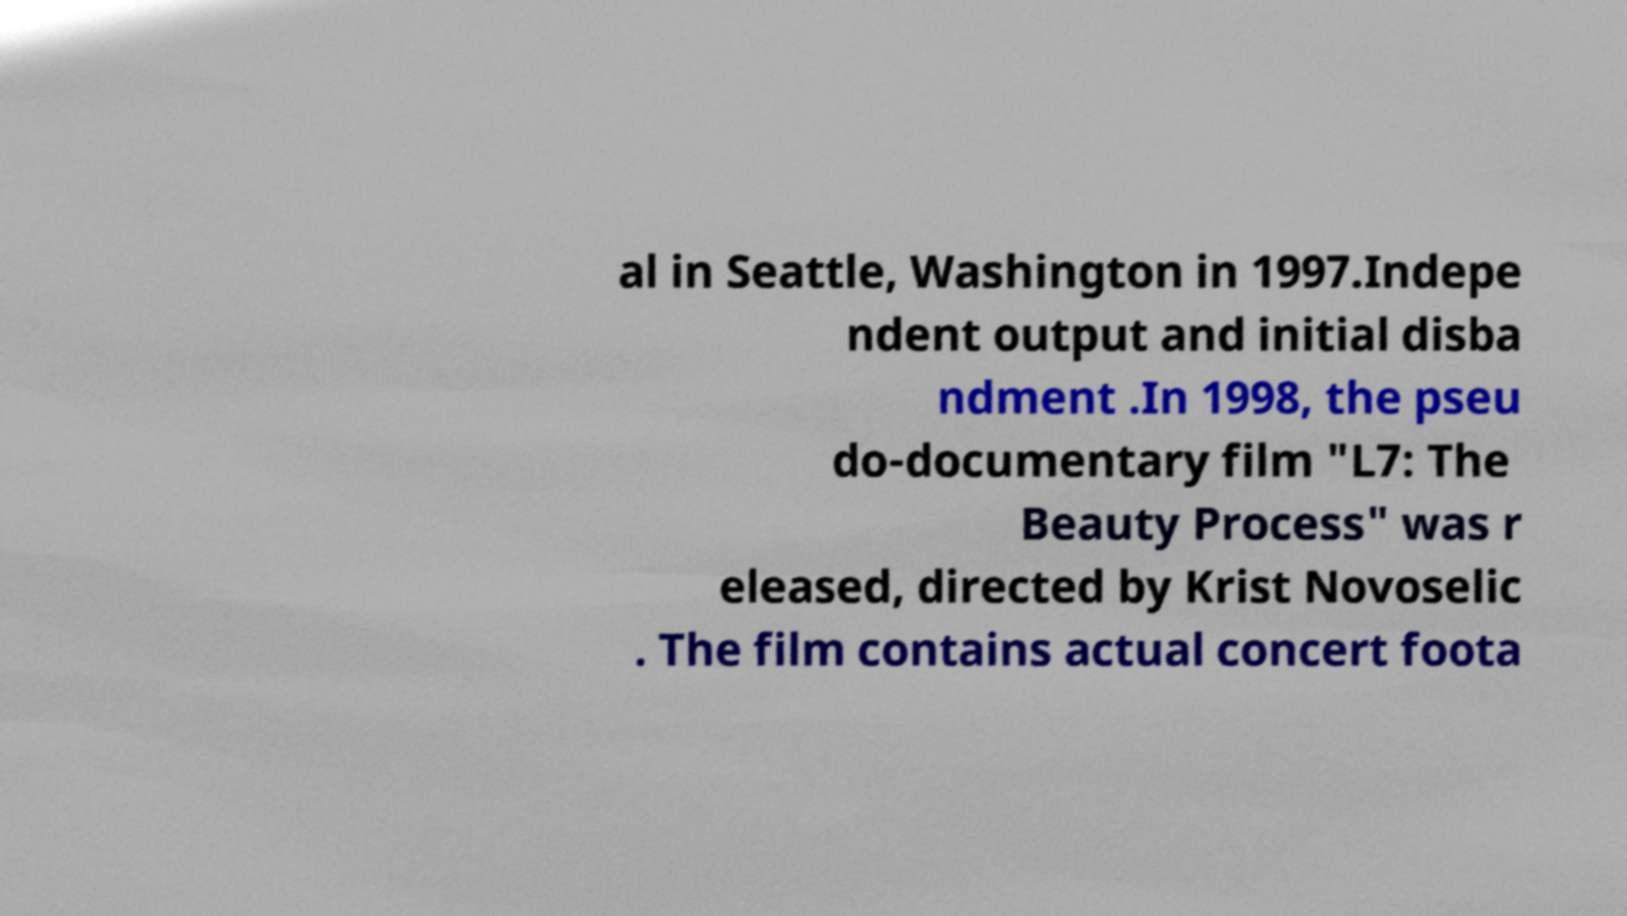Could you extract and type out the text from this image? al in Seattle, Washington in 1997.Indepe ndent output and initial disba ndment .In 1998, the pseu do-documentary film "L7: The Beauty Process" was r eleased, directed by Krist Novoselic . The film contains actual concert foota 